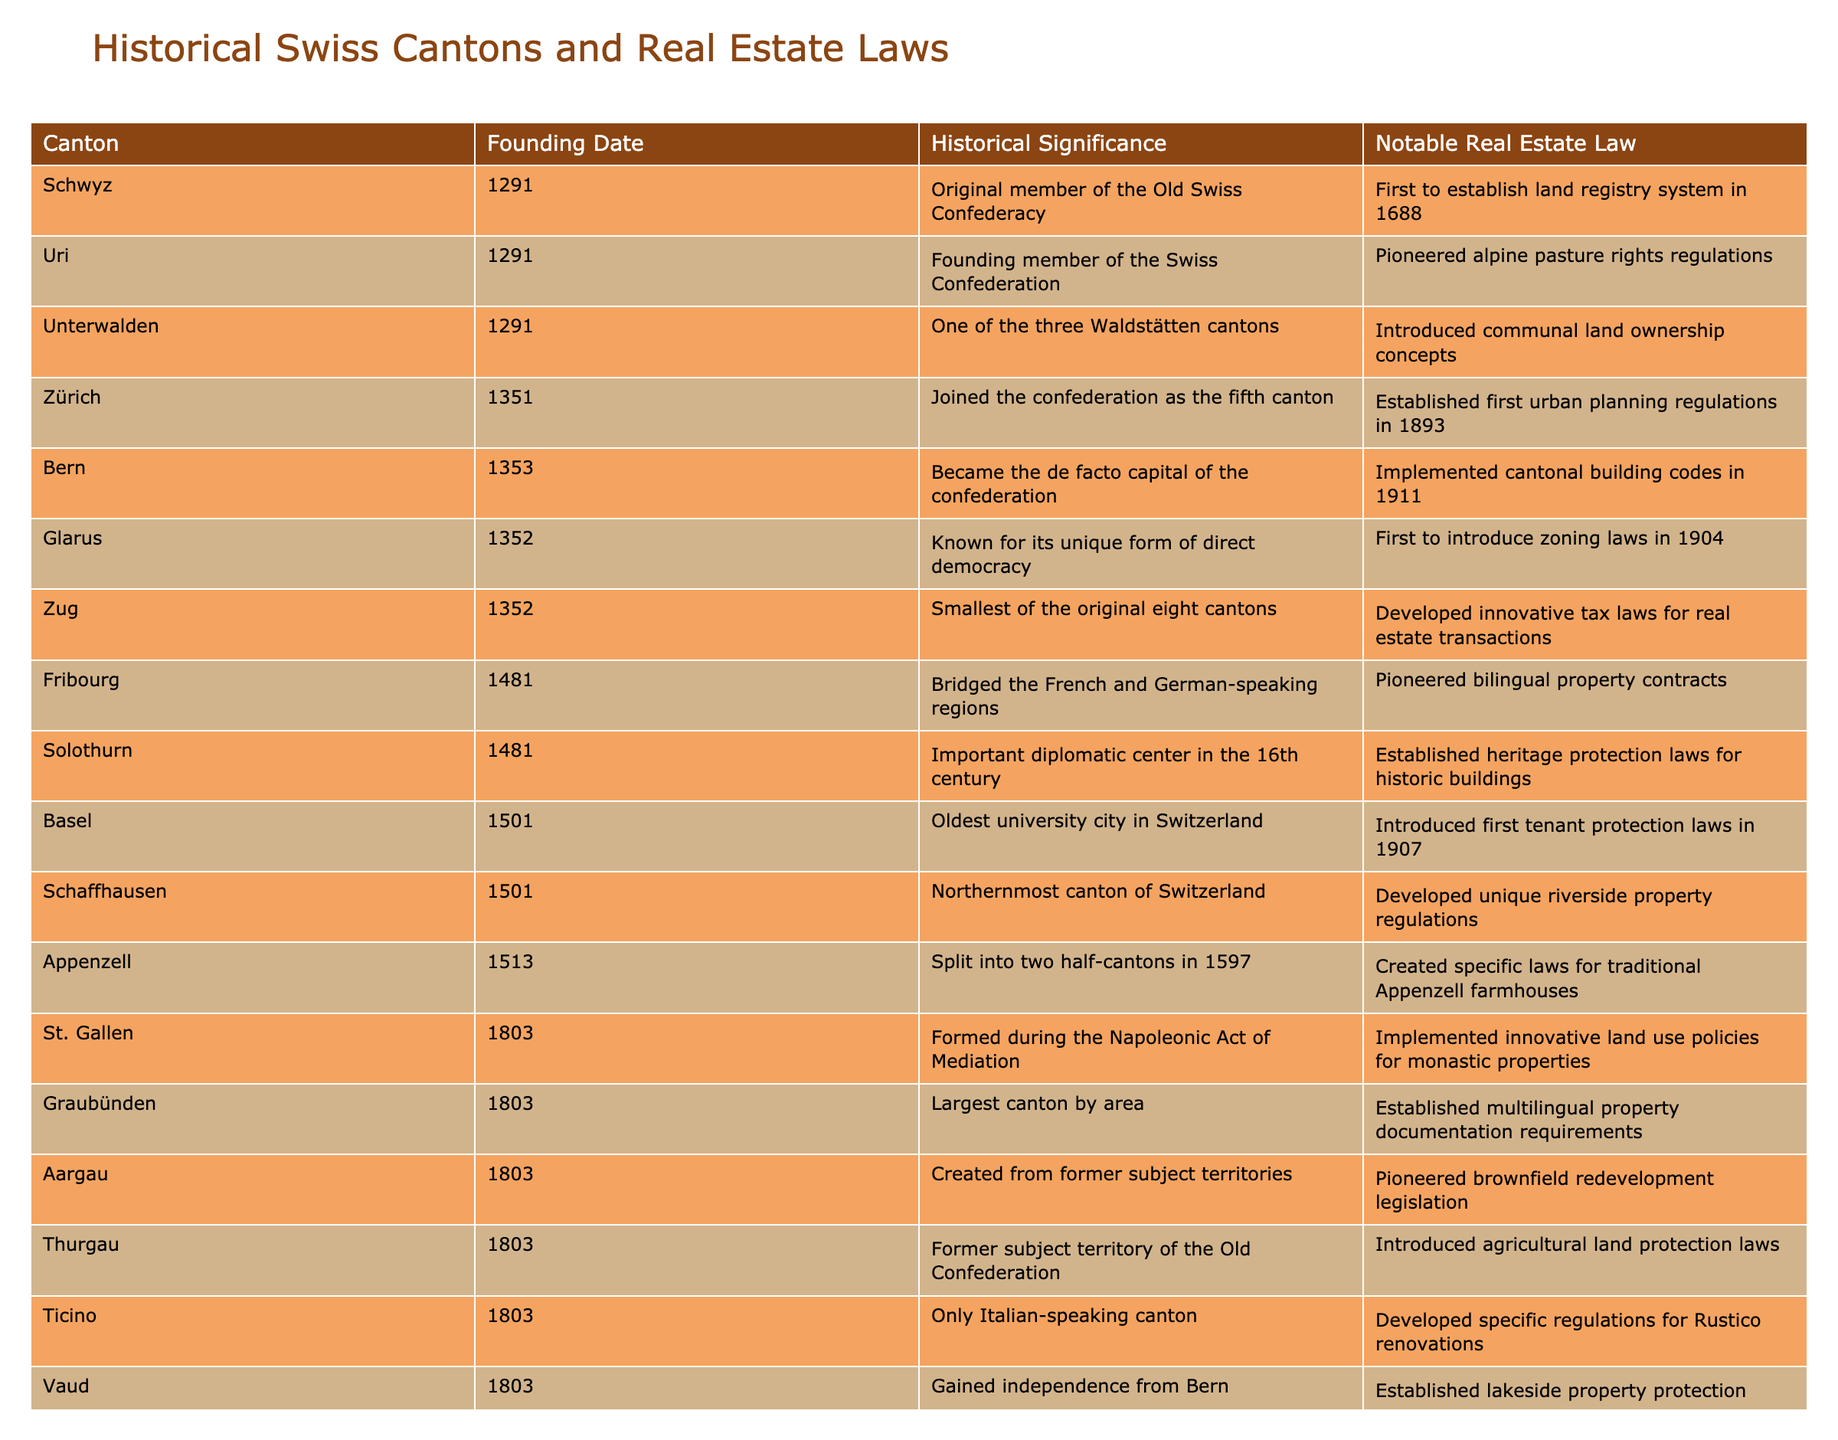What year was the Canton of Zürich founded? The founding date for Zürich is listed in the table under the "Founding Date" column. It states that Zürich was founded in 1351.
Answer: 1351 Which canton is known for introducing the first tenant protection laws? According to the table, Basel is the canton noted for introducing the first tenant protection laws in 1907, as indicated under the "Notable Real Estate Law" column.
Answer: Basel How many cantons were founded in the year 1803? By counting the entries in the "Founding Date" column for the year 1803, we find that there are five cantons (St. Gallen, Graubünden, Aargau, Thurgau, Ticino, and Vaud) that were founded in that year.
Answer: 5 Are there any cantons founded in the 15th century? The table reveals that there are two cantons founded in the 15th century: Fribourg (1481) and Solothurn (1481), therefore, the answer is yes.
Answer: Yes Which canton was the last to join before Jura, and what is its founding date? The table indicates that Geneva was the last canton to join before Jura, with a founding date of 1815, as stated in the respective columns.
Answer: Geneva, 1815 What is the difference in founding years between Bern and Geneva? Bern was founded in 1353 and Geneva in 1815. To find the difference, subtract 1353 from 1815, which gives us 462 years.
Answer: 462 years Which canton has the historical significance of being the oldest university city in Switzerland? The historical significance for Basel states it is the oldest university city in Switzerland, according to the "Historical Significance" column in the table.
Answer: Basel How many cantons established laws regarding land use policies? The table lists three cantons involved in establishing land use policies: St. Gallen (implemented innovative land use policies), Aargau (pioneered brownfield redevelopment legislation), and Ticino (developed specific regulations for Rustico renovations). Thus, there are three such cantons.
Answer: 3 Was Uri a founding member of the Swiss Confederation? Yes, the table confirms that Uri was a founding member of the Swiss Confederation, as mentioned in the "Historical Significance" column.
Answer: Yes 